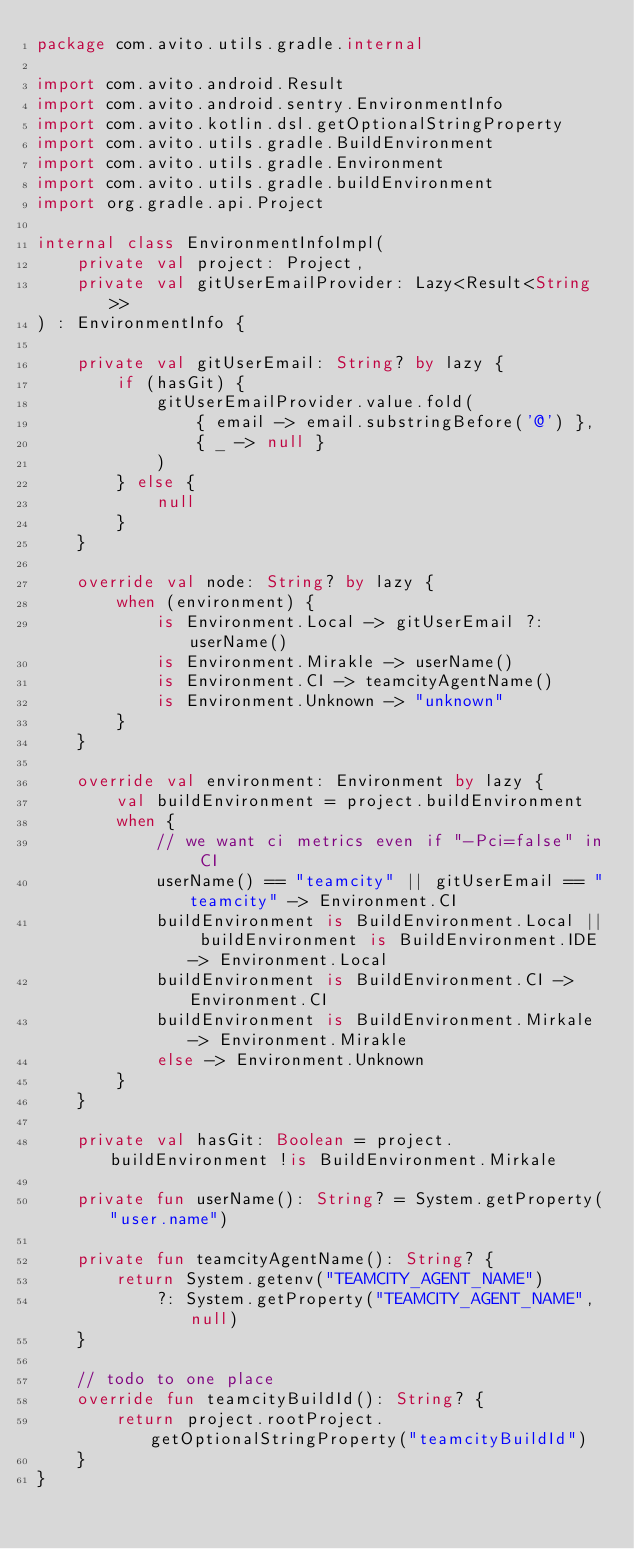<code> <loc_0><loc_0><loc_500><loc_500><_Kotlin_>package com.avito.utils.gradle.internal

import com.avito.android.Result
import com.avito.android.sentry.EnvironmentInfo
import com.avito.kotlin.dsl.getOptionalStringProperty
import com.avito.utils.gradle.BuildEnvironment
import com.avito.utils.gradle.Environment
import com.avito.utils.gradle.buildEnvironment
import org.gradle.api.Project

internal class EnvironmentInfoImpl(
    private val project: Project,
    private val gitUserEmailProvider: Lazy<Result<String>>
) : EnvironmentInfo {

    private val gitUserEmail: String? by lazy {
        if (hasGit) {
            gitUserEmailProvider.value.fold(
                { email -> email.substringBefore('@') },
                { _ -> null }
            )
        } else {
            null
        }
    }

    override val node: String? by lazy {
        when (environment) {
            is Environment.Local -> gitUserEmail ?: userName()
            is Environment.Mirakle -> userName()
            is Environment.CI -> teamcityAgentName()
            is Environment.Unknown -> "unknown"
        }
    }

    override val environment: Environment by lazy {
        val buildEnvironment = project.buildEnvironment
        when {
            // we want ci metrics even if "-Pci=false" in CI
            userName() == "teamcity" || gitUserEmail == "teamcity" -> Environment.CI
            buildEnvironment is BuildEnvironment.Local || buildEnvironment is BuildEnvironment.IDE -> Environment.Local
            buildEnvironment is BuildEnvironment.CI -> Environment.CI
            buildEnvironment is BuildEnvironment.Mirkale -> Environment.Mirakle
            else -> Environment.Unknown
        }
    }

    private val hasGit: Boolean = project.buildEnvironment !is BuildEnvironment.Mirkale

    private fun userName(): String? = System.getProperty("user.name")

    private fun teamcityAgentName(): String? {
        return System.getenv("TEAMCITY_AGENT_NAME")
            ?: System.getProperty("TEAMCITY_AGENT_NAME", null)
    }

    // todo to one place
    override fun teamcityBuildId(): String? {
        return project.rootProject.getOptionalStringProperty("teamcityBuildId")
    }
}
</code> 